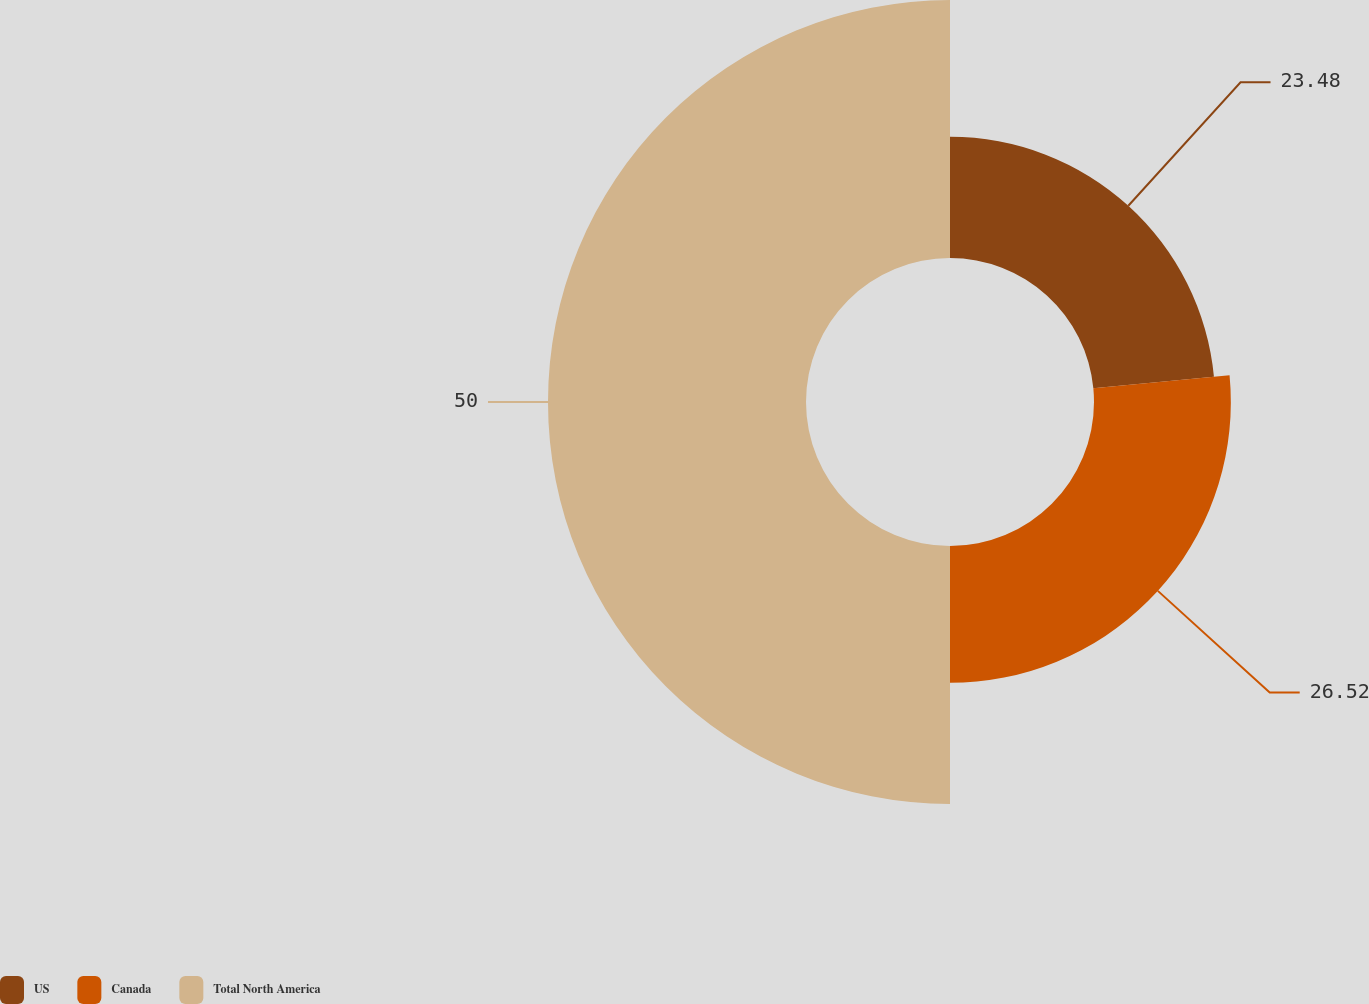Convert chart. <chart><loc_0><loc_0><loc_500><loc_500><pie_chart><fcel>US<fcel>Canada<fcel>Total North America<nl><fcel>23.48%<fcel>26.52%<fcel>50.0%<nl></chart> 